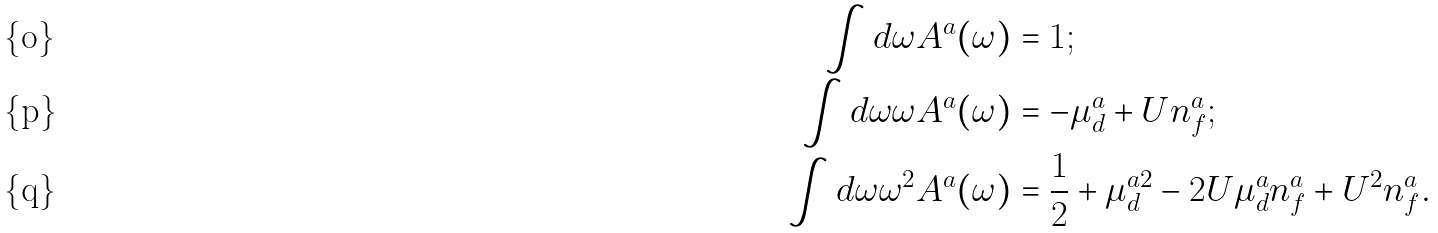<formula> <loc_0><loc_0><loc_500><loc_500>\int d \omega A ^ { a } ( \omega ) & = 1 ; \\ \int d \omega \omega A ^ { a } ( \omega ) & = - \mu _ { d } ^ { a } + U n _ { f } ^ { a } ; \\ \int d \omega \omega ^ { 2 } A ^ { a } ( \omega ) & = \frac { 1 } { 2 } + \mu _ { d } ^ { a 2 } - 2 U \mu _ { d } ^ { a } n _ { f } ^ { a } + U ^ { 2 } n _ { f } ^ { a } .</formula> 